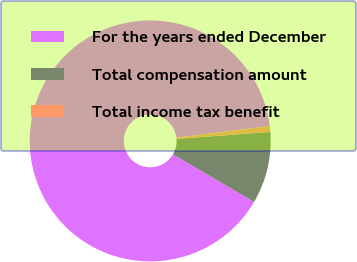Convert chart. <chart><loc_0><loc_0><loc_500><loc_500><pie_chart><fcel>For the years ended December<fcel>Total compensation amount<fcel>Total income tax benefit<nl><fcel>89.57%<fcel>9.65%<fcel>0.78%<nl></chart> 